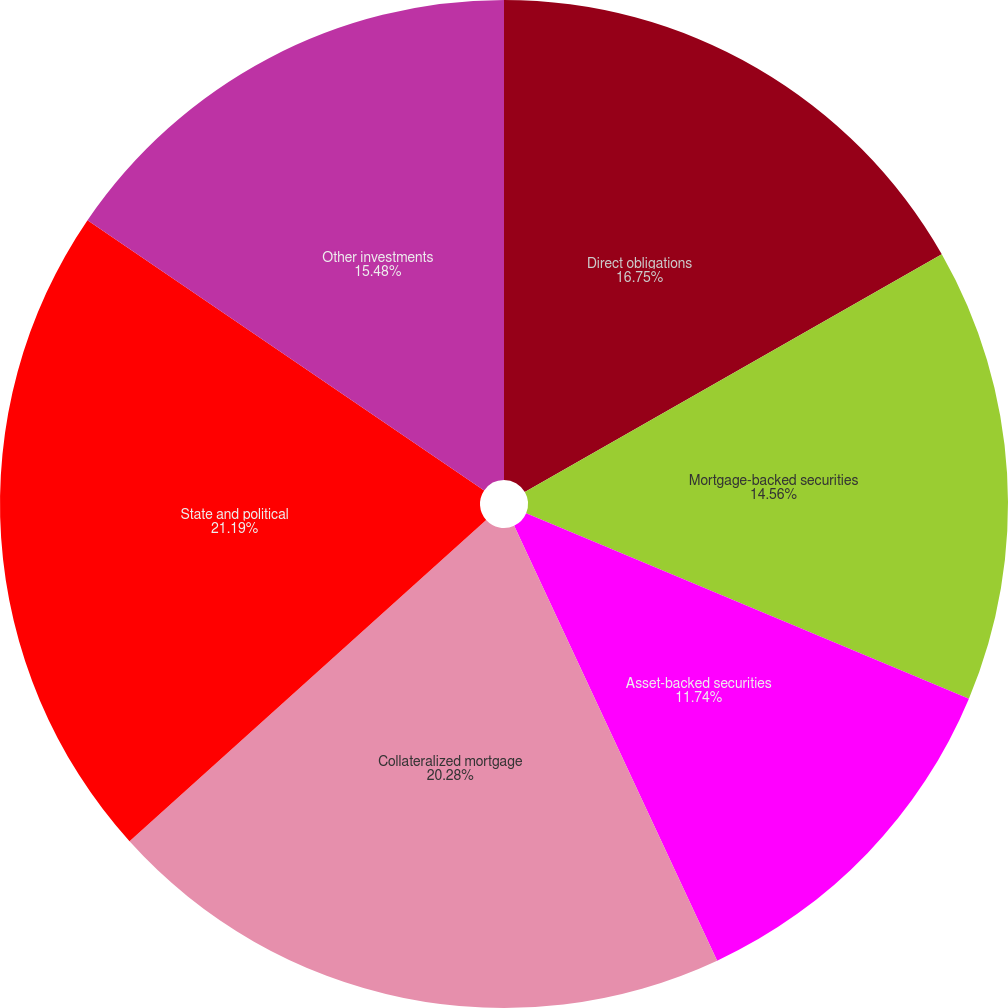<chart> <loc_0><loc_0><loc_500><loc_500><pie_chart><fcel>Direct obligations<fcel>Mortgage-backed securities<fcel>Asset-backed securities<fcel>Collateralized mortgage<fcel>State and political<fcel>Other investments<nl><fcel>16.75%<fcel>14.56%<fcel>11.74%<fcel>20.28%<fcel>21.19%<fcel>15.48%<nl></chart> 